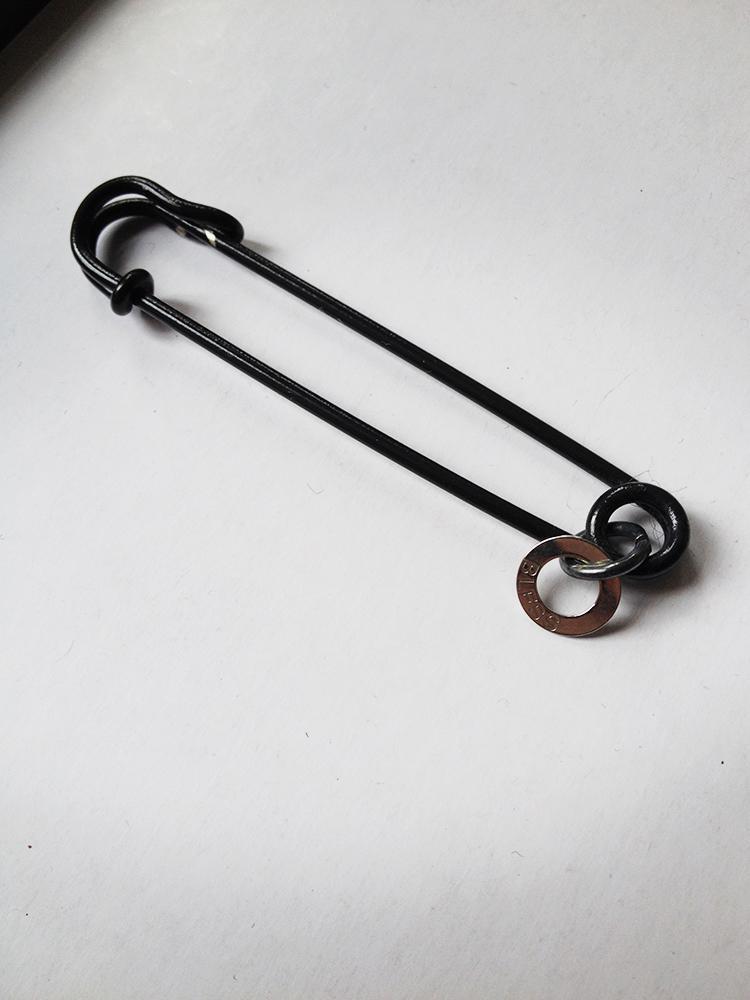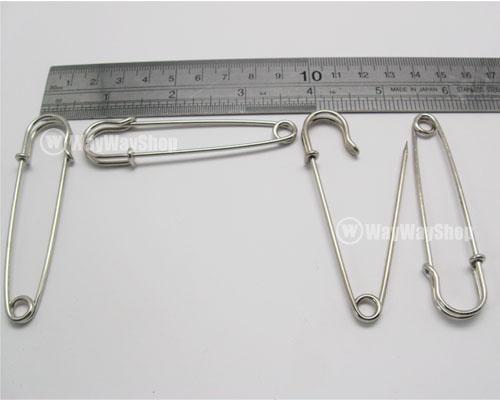The first image is the image on the left, the second image is the image on the right. Analyze the images presented: Is the assertion "There is one safety pin that is open." valid? Answer yes or no. Yes. 